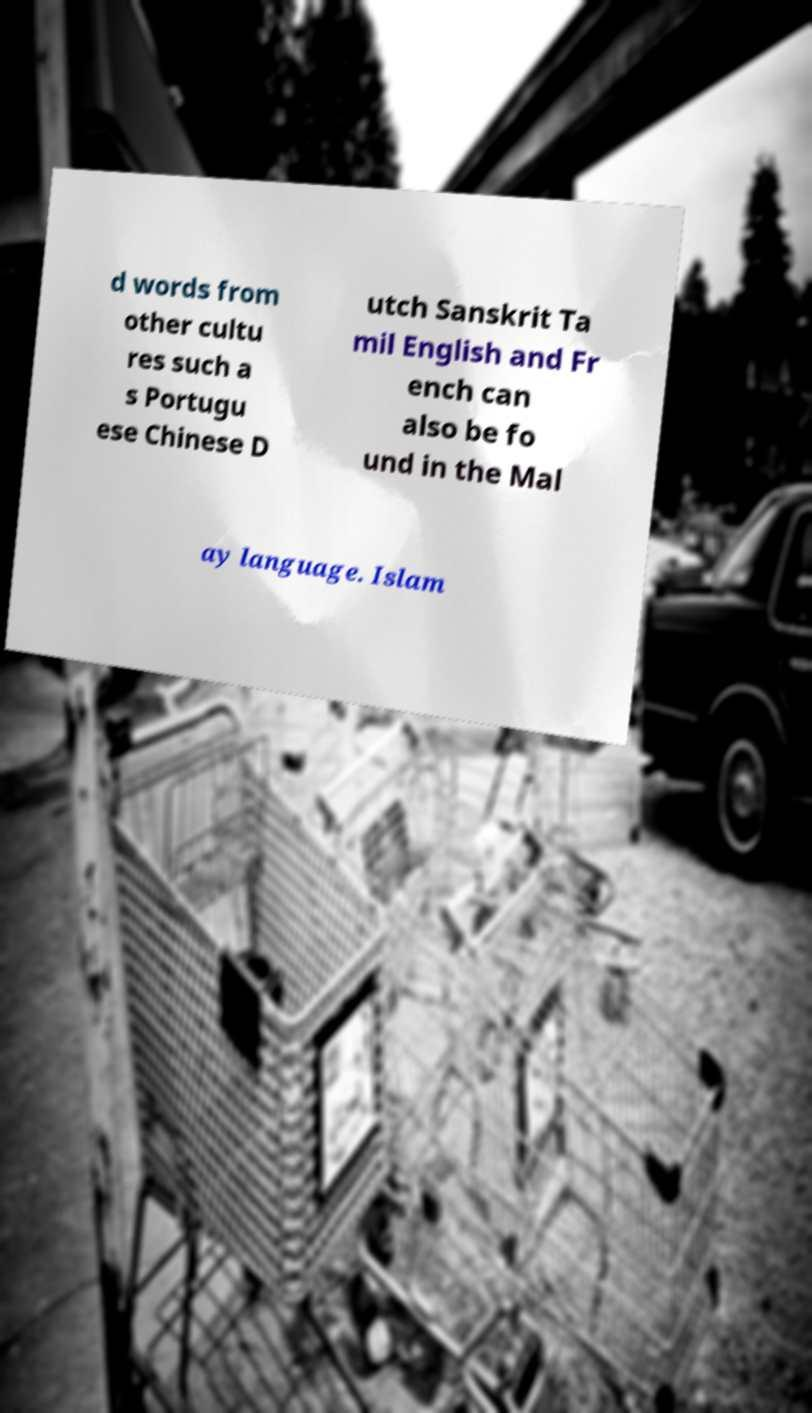I need the written content from this picture converted into text. Can you do that? d words from other cultu res such a s Portugu ese Chinese D utch Sanskrit Ta mil English and Fr ench can also be fo und in the Mal ay language. Islam 